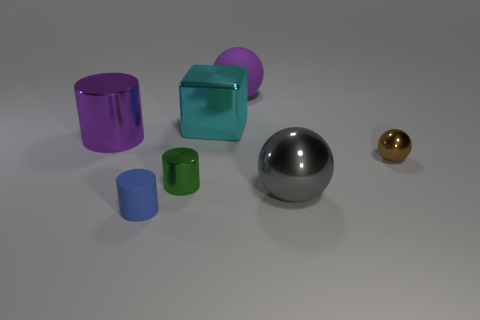Subtract all metallic balls. How many balls are left? 1 Add 1 small blue rubber objects. How many objects exist? 8 Subtract all green cylinders. How many cylinders are left? 2 Subtract all blocks. How many objects are left? 6 Subtract 1 cylinders. How many cylinders are left? 2 Subtract all blue cylinders. How many gray spheres are left? 1 Subtract all blue rubber cylinders. Subtract all large purple shiny things. How many objects are left? 5 Add 1 cyan cubes. How many cyan cubes are left? 2 Add 6 purple rubber spheres. How many purple rubber spheres exist? 7 Subtract 0 yellow cubes. How many objects are left? 7 